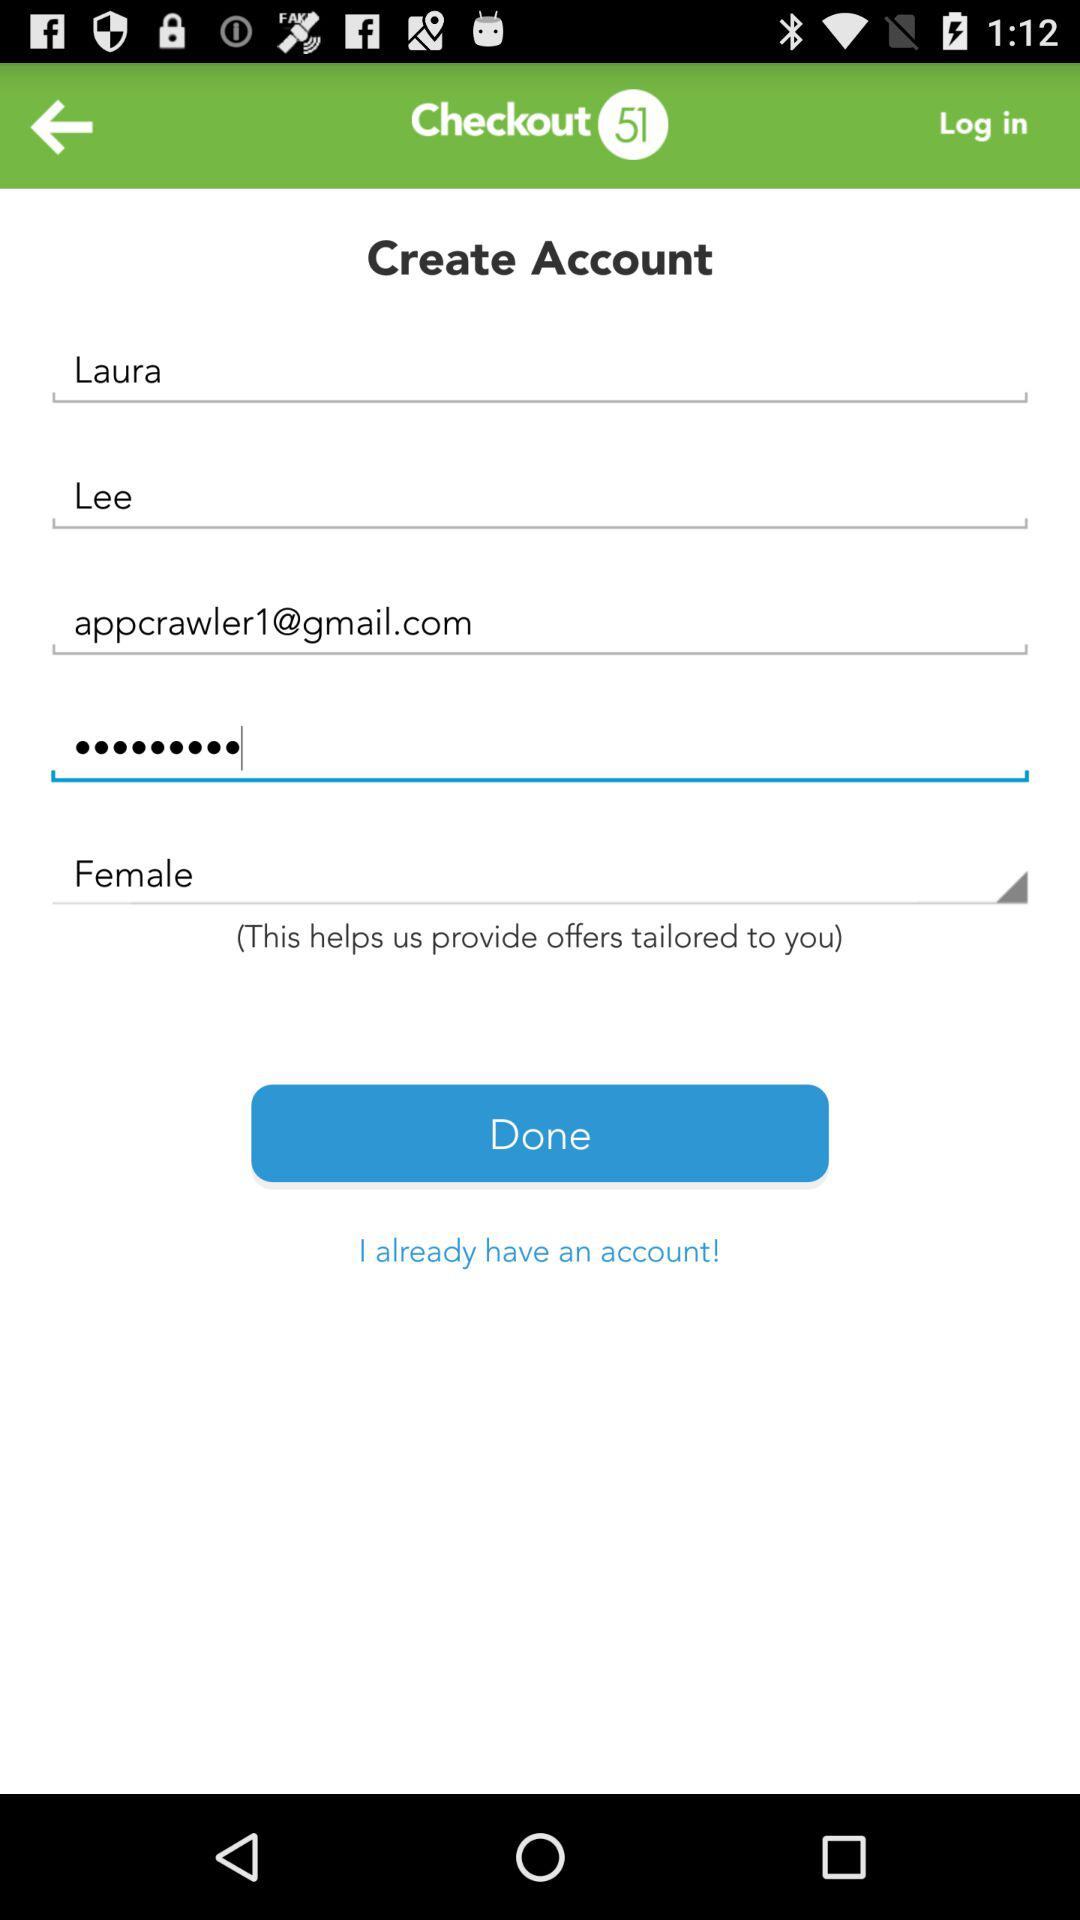What is the gender? The gender is female. 